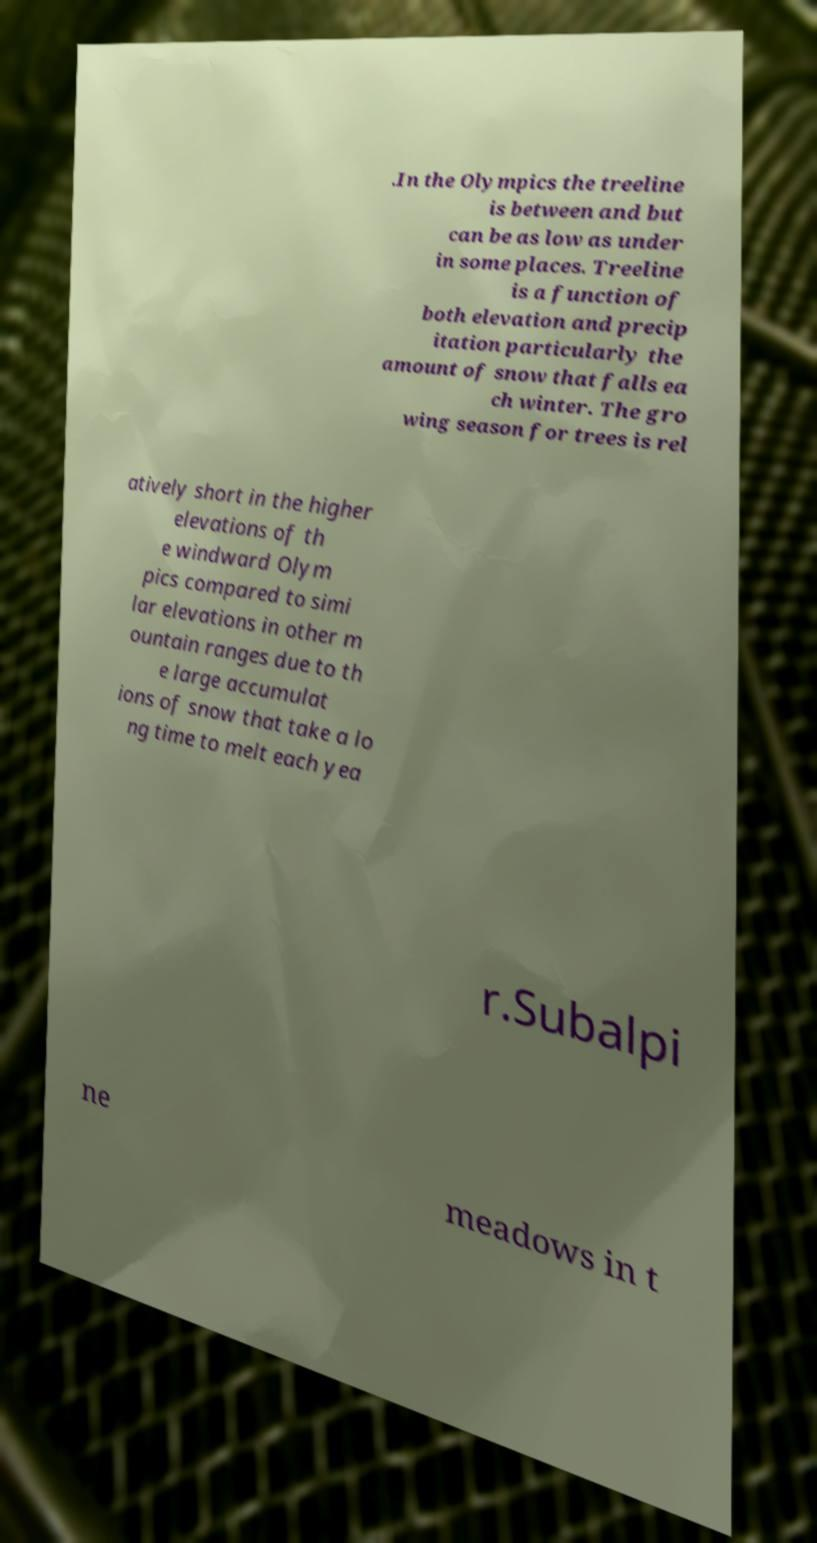Please identify and transcribe the text found in this image. .In the Olympics the treeline is between and but can be as low as under in some places. Treeline is a function of both elevation and precip itation particularly the amount of snow that falls ea ch winter. The gro wing season for trees is rel atively short in the higher elevations of th e windward Olym pics compared to simi lar elevations in other m ountain ranges due to th e large accumulat ions of snow that take a lo ng time to melt each yea r.Subalpi ne meadows in t 